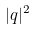Convert formula to latex. <formula><loc_0><loc_0><loc_500><loc_500>| q | ^ { 2 }</formula> 